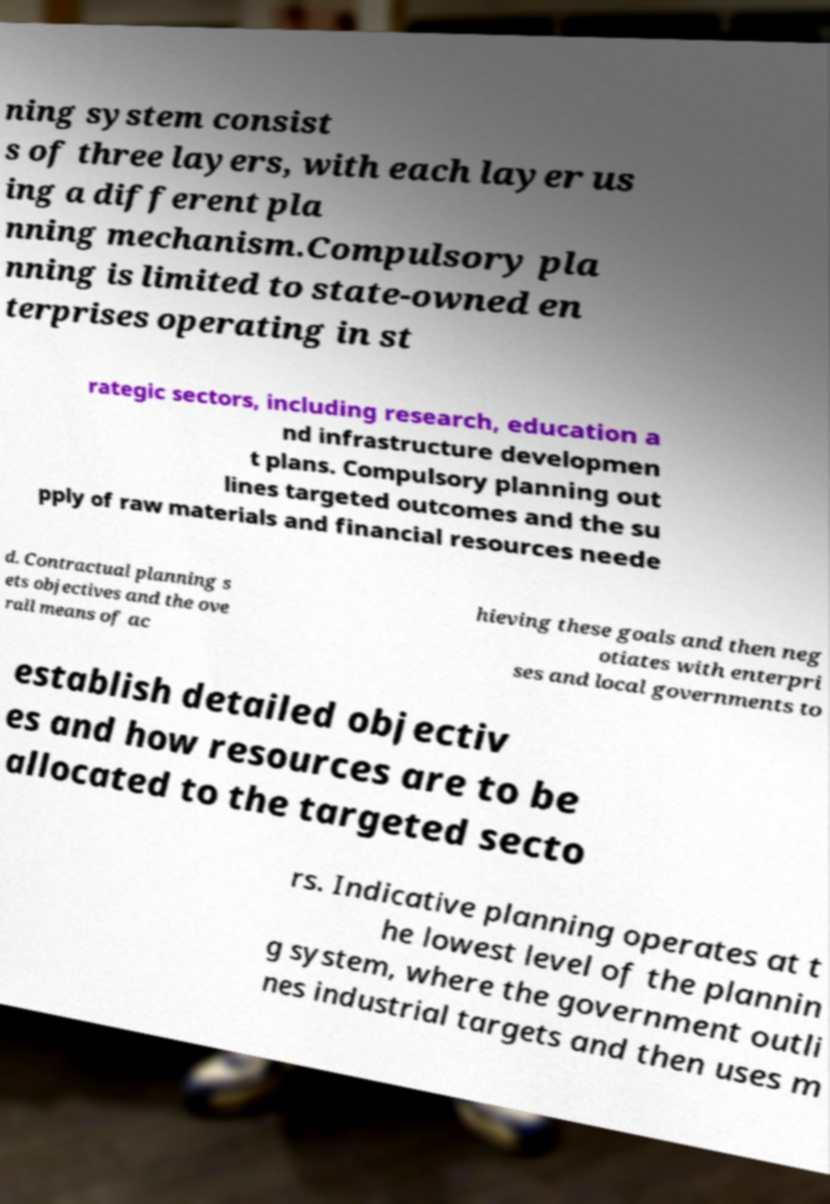I need the written content from this picture converted into text. Can you do that? ning system consist s of three layers, with each layer us ing a different pla nning mechanism.Compulsory pla nning is limited to state-owned en terprises operating in st rategic sectors, including research, education a nd infrastructure developmen t plans. Compulsory planning out lines targeted outcomes and the su pply of raw materials and financial resources neede d. Contractual planning s ets objectives and the ove rall means of ac hieving these goals and then neg otiates with enterpri ses and local governments to establish detailed objectiv es and how resources are to be allocated to the targeted secto rs. Indicative planning operates at t he lowest level of the plannin g system, where the government outli nes industrial targets and then uses m 